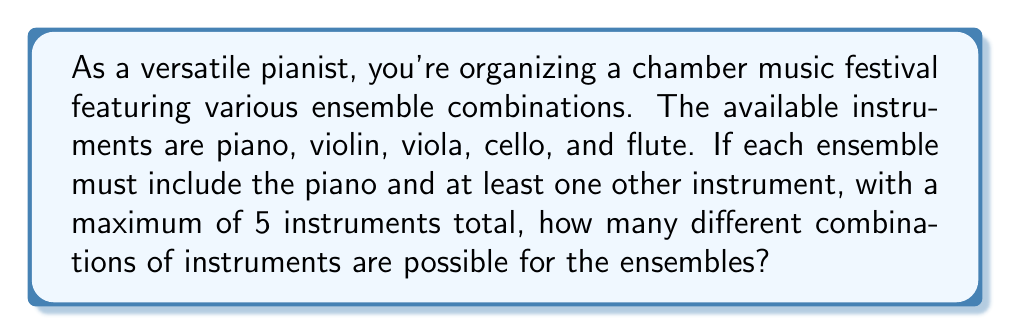Give your solution to this math problem. Let's approach this step-by-step:

1) The piano is always included, so we need to consider the combinations of the other 4 instruments (violin, viola, cello, flute).

2) We can have ensembles with 2, 3, 4, or 5 instruments (including the piano).

3) For each size, we need to calculate the number of ways to choose the other instruments:

   - 2 instruments: $\binom{4}{1}$ (choosing 1 from 4)
   - 3 instruments: $\binom{4}{2}$ (choosing 2 from 4)
   - 4 instruments: $\binom{4}{3}$ (choosing 3 from 4)
   - 5 instruments: $\binom{4}{4}$ (choosing all 4)

4) Using the combination formula:

   $\binom{4}{1} = 4$
   $\binom{4}{2} = 6$
   $\binom{4}{3} = 4$
   $\binom{4}{4} = 1$

5) The total number of combinations is the sum of these:

   $$4 + 6 + 4 + 1 = 15$$

Therefore, there are 15 different possible combinations of instruments for the ensembles.
Answer: 15 combinations 